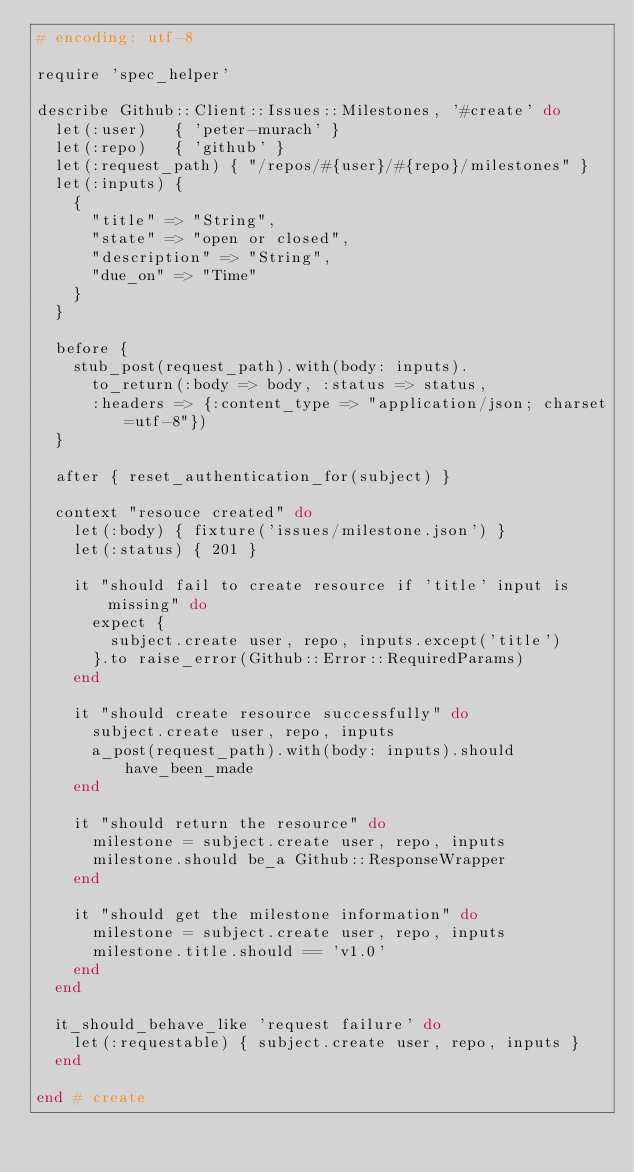Convert code to text. <code><loc_0><loc_0><loc_500><loc_500><_Ruby_># encoding: utf-8

require 'spec_helper'

describe Github::Client::Issues::Milestones, '#create' do
  let(:user)   { 'peter-murach' }
  let(:repo)   { 'github' }
  let(:request_path) { "/repos/#{user}/#{repo}/milestones" }
  let(:inputs) {
    {
      "title" => "String",
      "state" => "open or closed",
      "description" => "String",
      "due_on" => "Time"
    }
  }

  before {
    stub_post(request_path).with(body: inputs).
      to_return(:body => body, :status => status,
      :headers => {:content_type => "application/json; charset=utf-8"})
  }

  after { reset_authentication_for(subject) }

  context "resouce created" do
    let(:body) { fixture('issues/milestone.json') }
    let(:status) { 201 }

    it "should fail to create resource if 'title' input is missing" do
      expect {
        subject.create user, repo, inputs.except('title')
      }.to raise_error(Github::Error::RequiredParams)
    end

    it "should create resource successfully" do
      subject.create user, repo, inputs
      a_post(request_path).with(body: inputs).should have_been_made
    end

    it "should return the resource" do
      milestone = subject.create user, repo, inputs
      milestone.should be_a Github::ResponseWrapper
    end

    it "should get the milestone information" do
      milestone = subject.create user, repo, inputs
      milestone.title.should == 'v1.0'
    end
  end

  it_should_behave_like 'request failure' do
    let(:requestable) { subject.create user, repo, inputs }
  end

end # create
</code> 